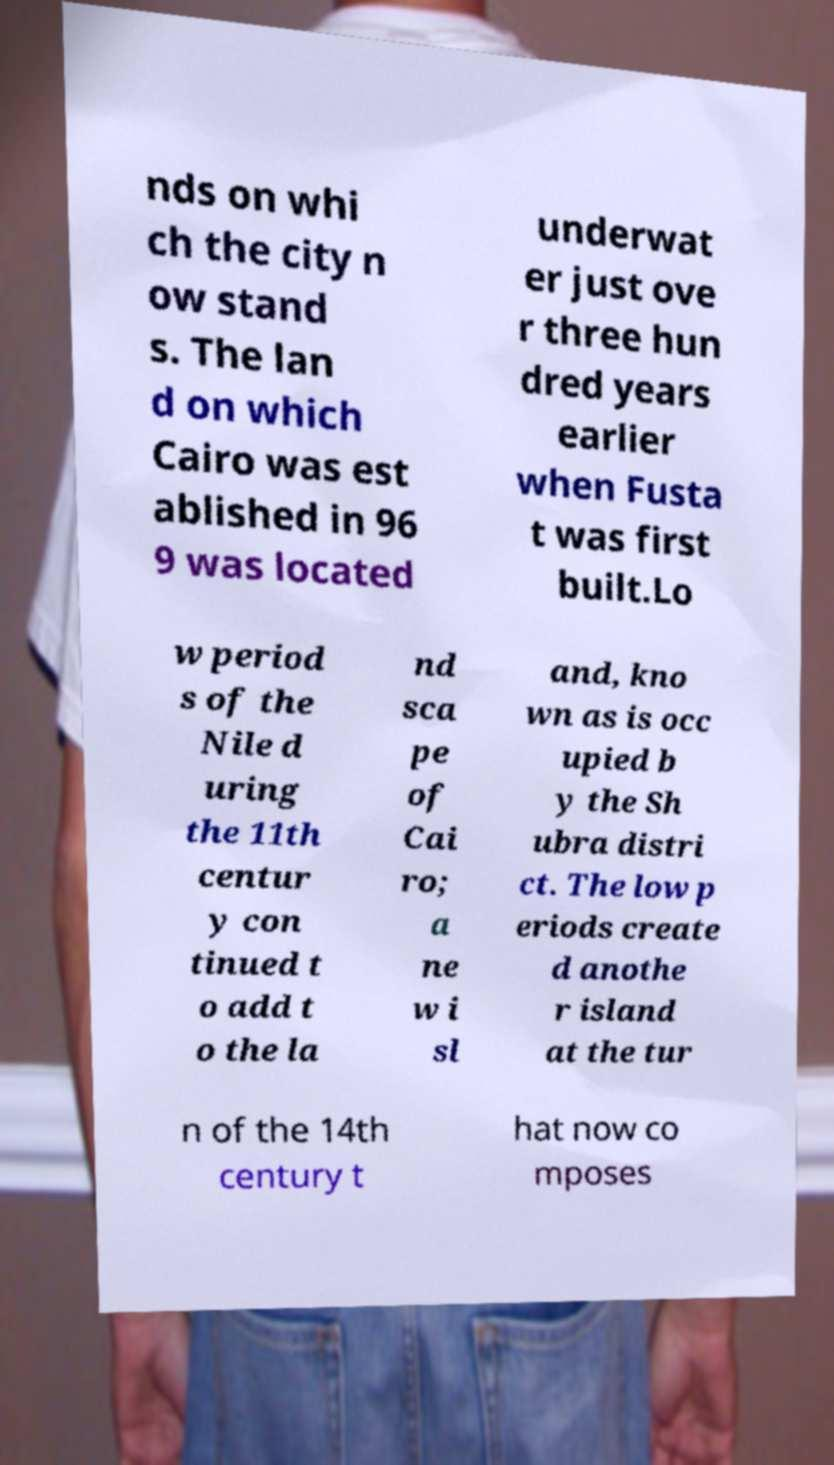Please identify and transcribe the text found in this image. nds on whi ch the city n ow stand s. The lan d on which Cairo was est ablished in 96 9 was located underwat er just ove r three hun dred years earlier when Fusta t was first built.Lo w period s of the Nile d uring the 11th centur y con tinued t o add t o the la nd sca pe of Cai ro; a ne w i sl and, kno wn as is occ upied b y the Sh ubra distri ct. The low p eriods create d anothe r island at the tur n of the 14th century t hat now co mposes 